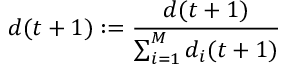<formula> <loc_0><loc_0><loc_500><loc_500>d ( t + 1 ) \colon = \frac { d ( t + 1 ) } { \sum _ { i = 1 } ^ { M } d _ { i } ( t + 1 ) }</formula> 